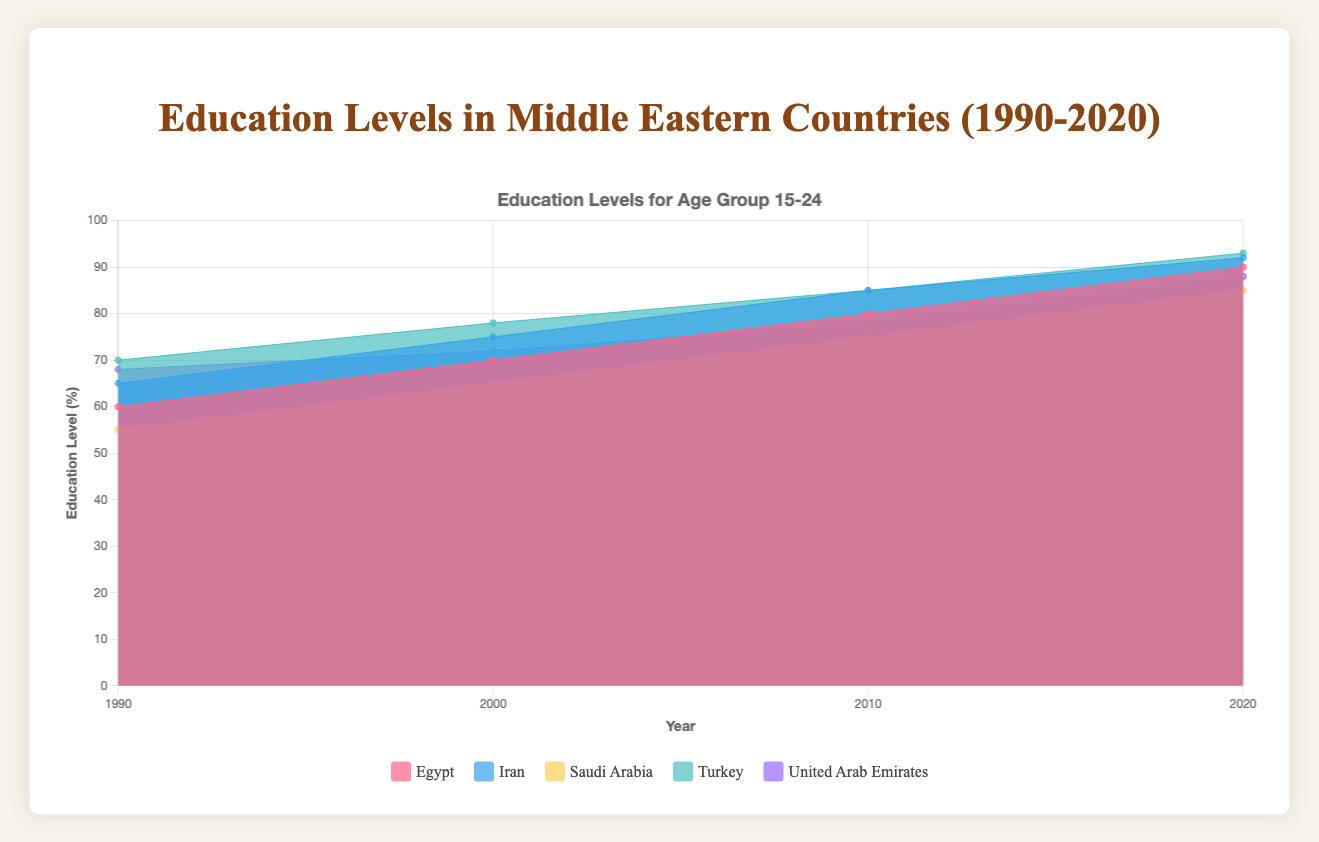What is the overall trend of the education levels in the 15 to 24 age group for Egypt over the years? The data shows that the education levels in the 15 to 24 age group in Egypt increase consistently over the years from 60% in 1990 to 90% in 2020.
Answer: Increasing Which country had the highest education level for the 15 to 24 age group in 2020? In 2020, Turkey had the highest education level for the 15 to 24 age group, reaching 93%.
Answer: Turkey How does the education level of Saudi Arabia in the 25 to 34 age group in 2000 compare to the 15 to 24 age group in the same year? In 2000, Saudi Arabia had an education level of 60% for the 25 to 34 age group, while it was 65% for the 15 to 24 age group. Therefore, the education level is higher in the younger age group.
Answer: 15 to 24 group is higher What is the average education level of the 15 to 24 age group across all countries in 2010? The education levels for the 15 to 24 age group in various countries in 2010 are 80% (Egypt), 85% (Iran), 75% (Saudi Arabia), 85% (Turkey), and 78% (United Arab Emirates). The average is (80 + 85 + 75 + 85 + 78)/5 = 80.6%.
Answer: 80.6% What is the difference between education levels for the age groups 35 to 44 and 45 to 54 in Egypt in 2020? The education level for the 35 to 44 age group in Egypt in 2020 is 75%, and for the 45 to 54 age group, it is 70%. The difference is 75% - 70% = 5%.
Answer: 5% Between Turkey and Iran, which country had a higher education level in the 25 to 34 age group in 2010? In 2010, Turkey had an education level of 84% for the 25 to 34 age group, while Iran had 82%. Therefore, Turkey had a higher education level.
Answer: Turkey Identify the age group with the largest increase in education levels in UAE from 1990 to 2020. The 45 to 54 age group in UAE shows an increase from 35% in 1990 to 78% in 2020, an increase of 43%.
Answer: 45 to 54 Which country shows the smallest increase in education levels for the 25 to 34 age group from 1990 to 2020? Saudi Arabia had an education level increase from 45% in 1990 to 83% in 2020, an increase of 38%, which is the smallest among the given countries.
Answer: Saudi Arabia 